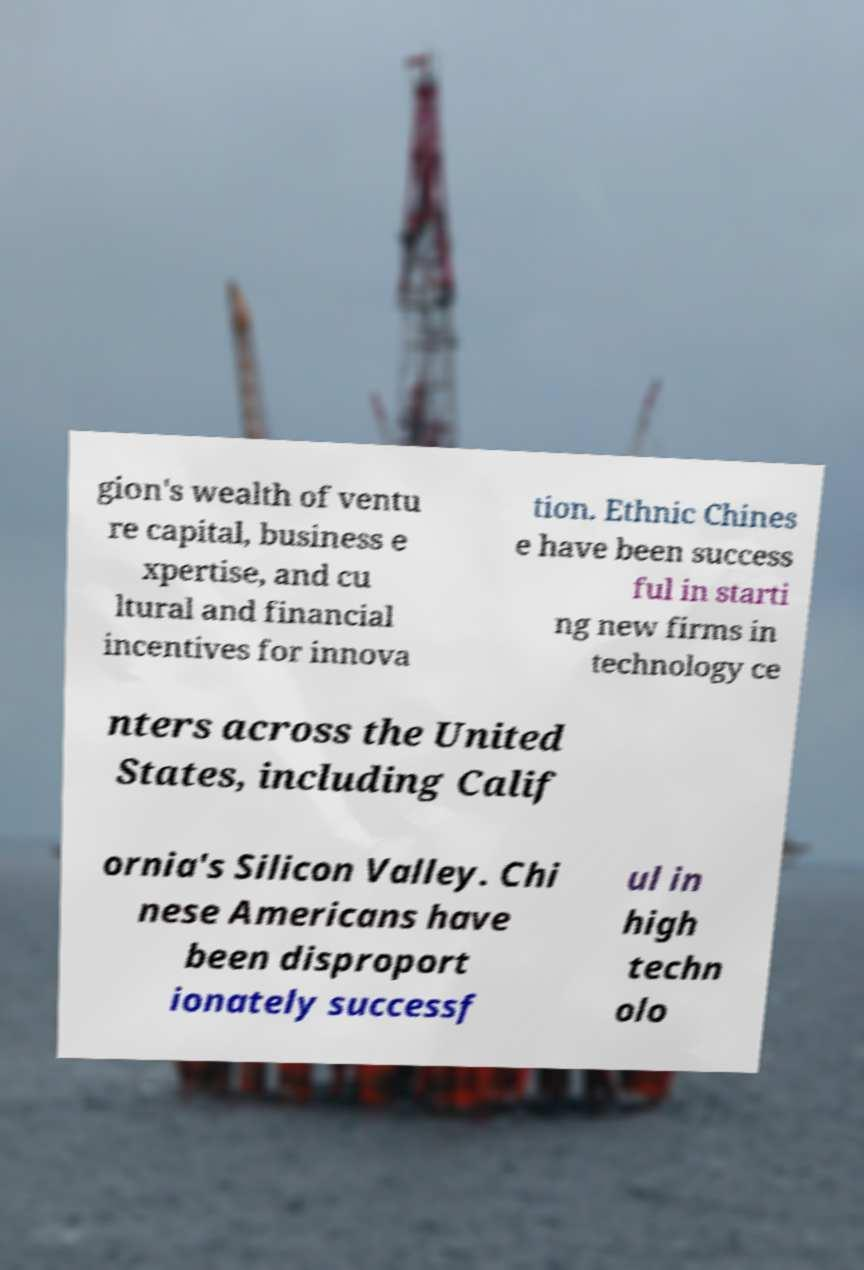Please identify and transcribe the text found in this image. gion's wealth of ventu re capital, business e xpertise, and cu ltural and financial incentives for innova tion. Ethnic Chines e have been success ful in starti ng new firms in technology ce nters across the United States, including Calif ornia's Silicon Valley. Chi nese Americans have been disproport ionately successf ul in high techn olo 